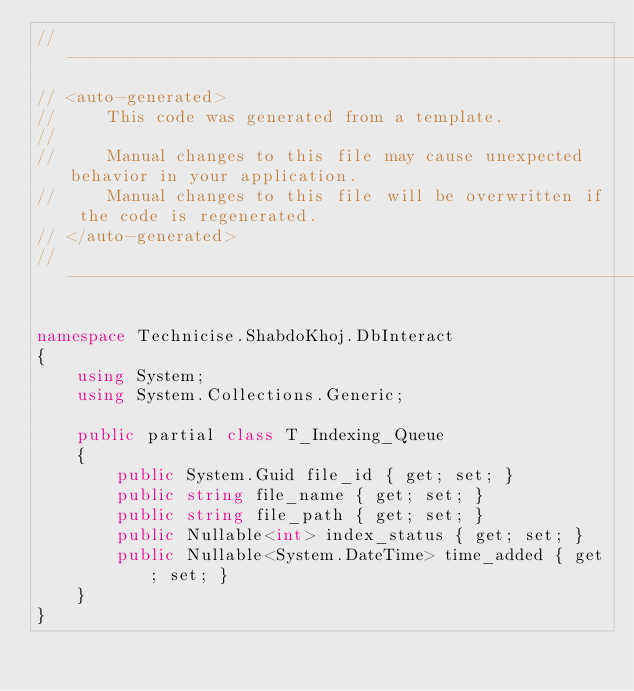Convert code to text. <code><loc_0><loc_0><loc_500><loc_500><_C#_>//------------------------------------------------------------------------------
// <auto-generated>
//     This code was generated from a template.
//
//     Manual changes to this file may cause unexpected behavior in your application.
//     Manual changes to this file will be overwritten if the code is regenerated.
// </auto-generated>
//------------------------------------------------------------------------------

namespace Technicise.ShabdoKhoj.DbInteract
{
    using System;
    using System.Collections.Generic;
    
    public partial class T_Indexing_Queue
    {
        public System.Guid file_id { get; set; }
        public string file_name { get; set; }
        public string file_path { get; set; }
        public Nullable<int> index_status { get; set; }
        public Nullable<System.DateTime> time_added { get; set; }
    }
}
</code> 